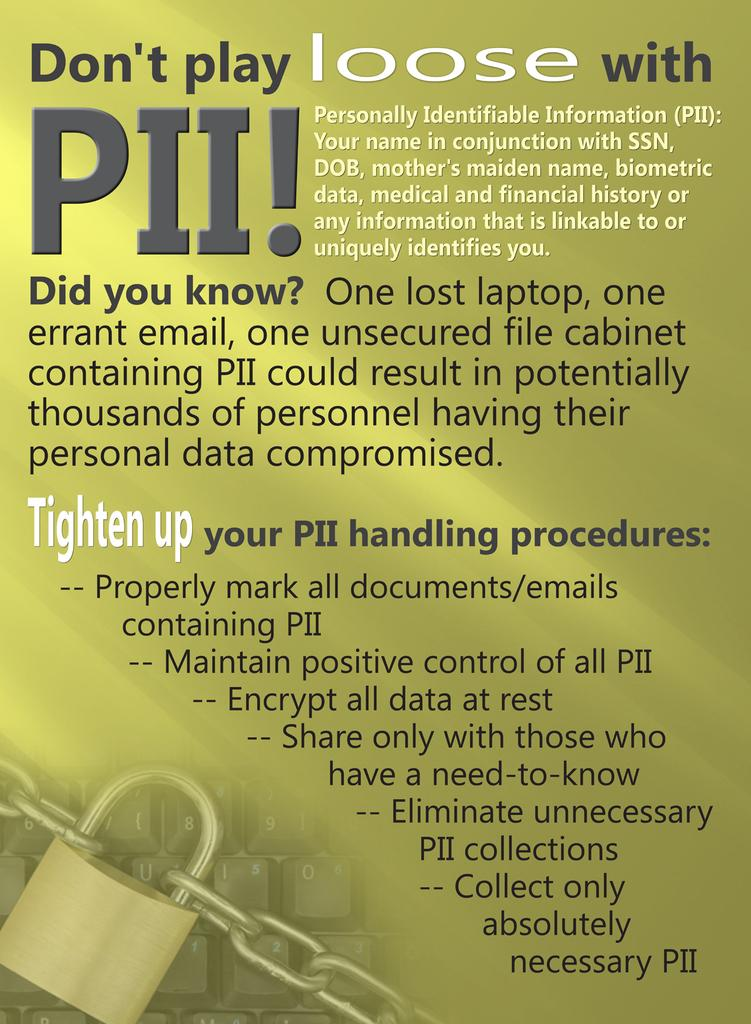<image>
Describe the image concisely. An image of a lock with "don't play loose with PII." 